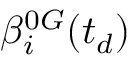Convert formula to latex. <formula><loc_0><loc_0><loc_500><loc_500>\beta _ { i } ^ { 0 G } ( t _ { d } )</formula> 